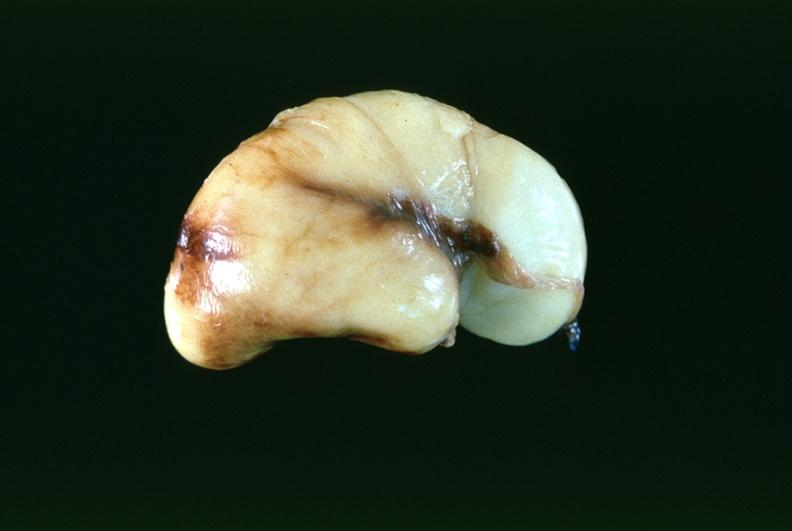what is present?
Answer the question using a single word or phrase. Nervous 